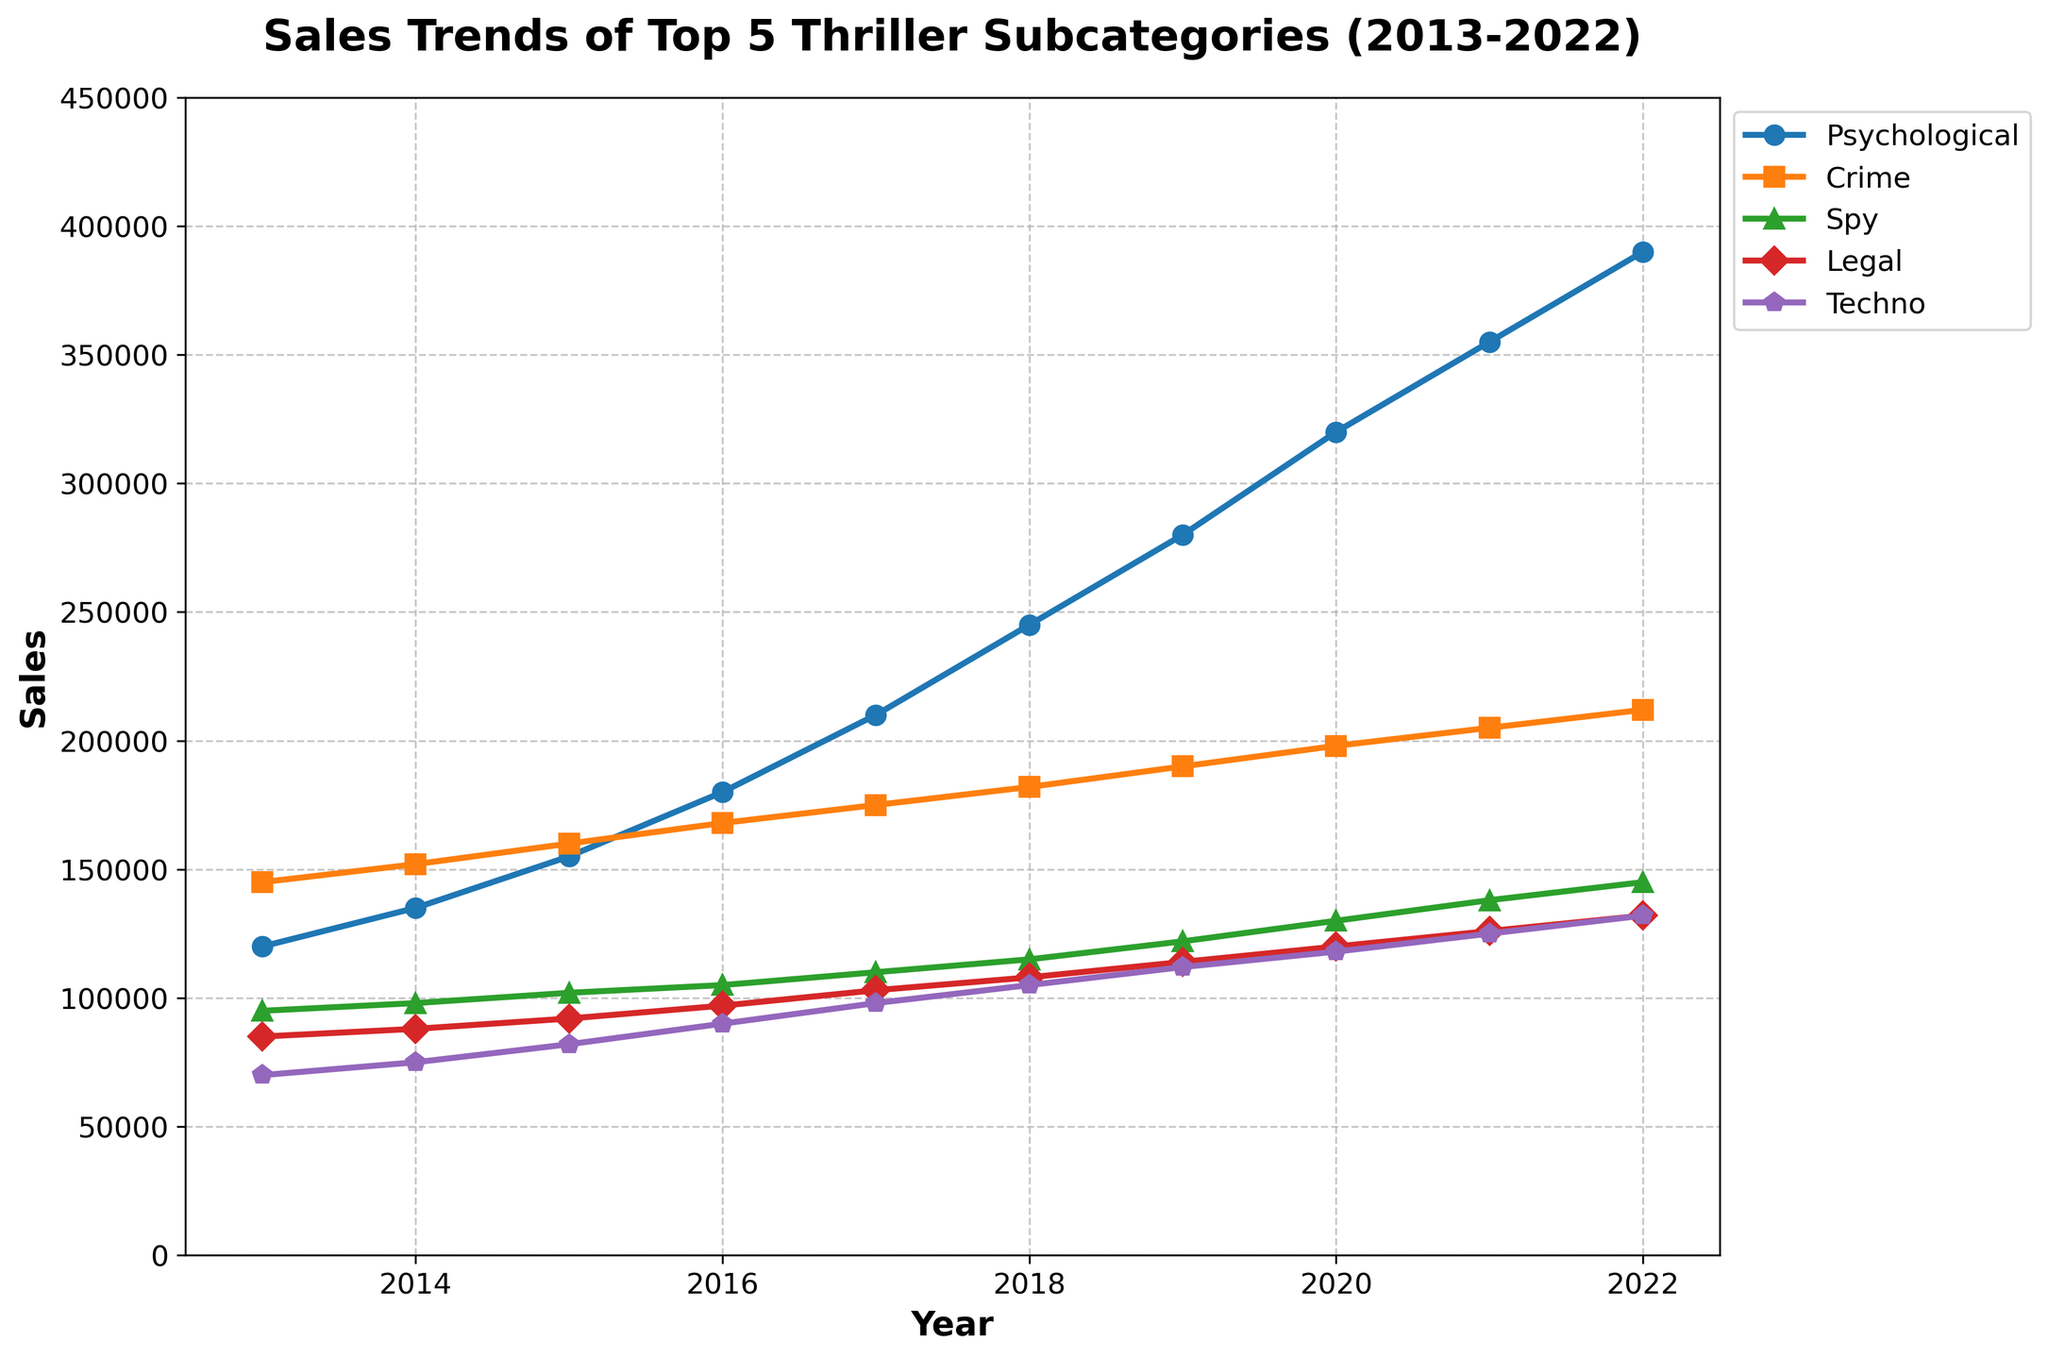Which thriller subcategory had the highest sales in 2022? Look at the endpoint on the lines for the year 2022 and compare the values. The 'Psychological' subcategory has the highest point among all.
Answer: Psychological What is the title of the figure? The title is shown prominently at the top of the figure.
Answer: Sales Trends of Top 5 Thriller Subcategories (2013-2022) How did the sales of the 'Crime' subcategory change from 2013 to 2018? Look at the line for 'Crime' from 2013 to 2018 and note the trend. The sales increased from 145,000 to 182,000.
Answer: Increased Which year saw the largest single-year increase in sales for the 'Psychological' subcategory? Compare the year-over-year differences for the 'Psychological' subcategory line. The largest increase is from 2016 to 2017 (30,000).
Answer: 2017 On average, how many sales did the 'Techno' subcategory have per year over the last decade? Sum the sales figures for 'Techno' from 2013 to 2022 and divide by the number of years. (70,000 + 75,000 + 82,000 + 90,000 + 98,000 + 105,000 + 112,000 + 118,000 + 125,000 + 132,000)/10 = 100,700
Answer: 100,700 Which subcategory had the most consistent growth in sales over the past decade? Look at the slopes of all lines. 'Psychological' has the steadiest positive slope over all years.
Answer: Psychological In which year did the 'Spy' subcategory outperform the 'Legal' subcategory in sales for the first time? Compare the 'Spy' and 'Legal' lines year by year. 'Spy' sales surpassed 'Legal' in 2016.
Answer: 2016 By how much did the sales of 'Legal' thrillers increase from 2013 to 2022? Calculate the difference between the sales figures for 'Legal' in 2022 and 2013. 132,000 - 85,000 = 47,000
Answer: 47,000 Did any subcategory experience a decline in sales over any part of the decade? Check the trend of each line. All subcategories experienced year-over-year sales increases without a decline.
Answer: No What is the average annual growth rate for the 'Techno' subcategory? Calculate the overall growth from 2013 to 2022 and then find the average increase per year. (132,000 - 70,000) / 9 ≈ 6,889
Answer: 6,889 